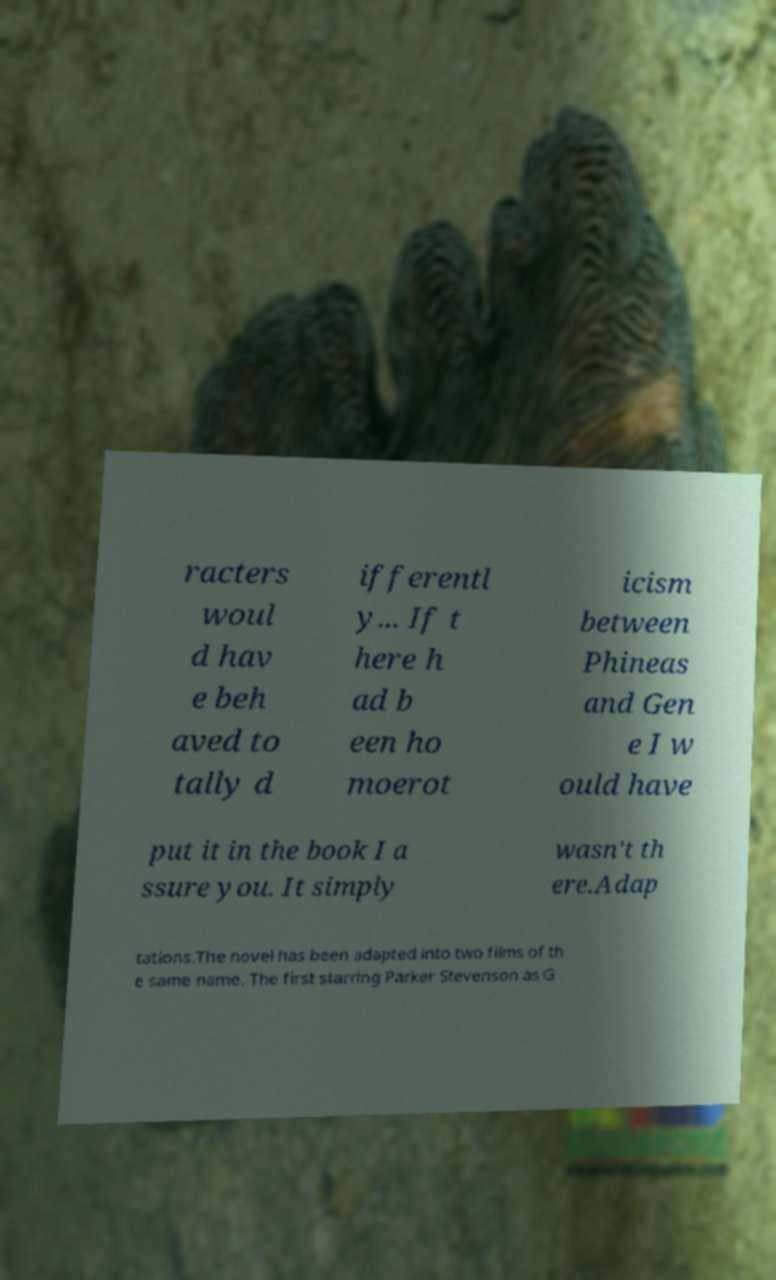For documentation purposes, I need the text within this image transcribed. Could you provide that? racters woul d hav e beh aved to tally d ifferentl y... If t here h ad b een ho moerot icism between Phineas and Gen e I w ould have put it in the book I a ssure you. It simply wasn't th ere.Adap tations.The novel has been adapted into two films of th e same name. The first starring Parker Stevenson as G 